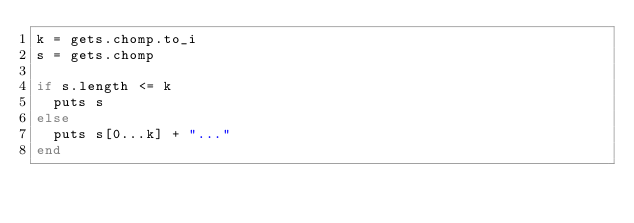Convert code to text. <code><loc_0><loc_0><loc_500><loc_500><_Ruby_>k = gets.chomp.to_i
s = gets.chomp

if s.length <= k
  puts s
else
  puts s[0...k] + "..."
end
</code> 